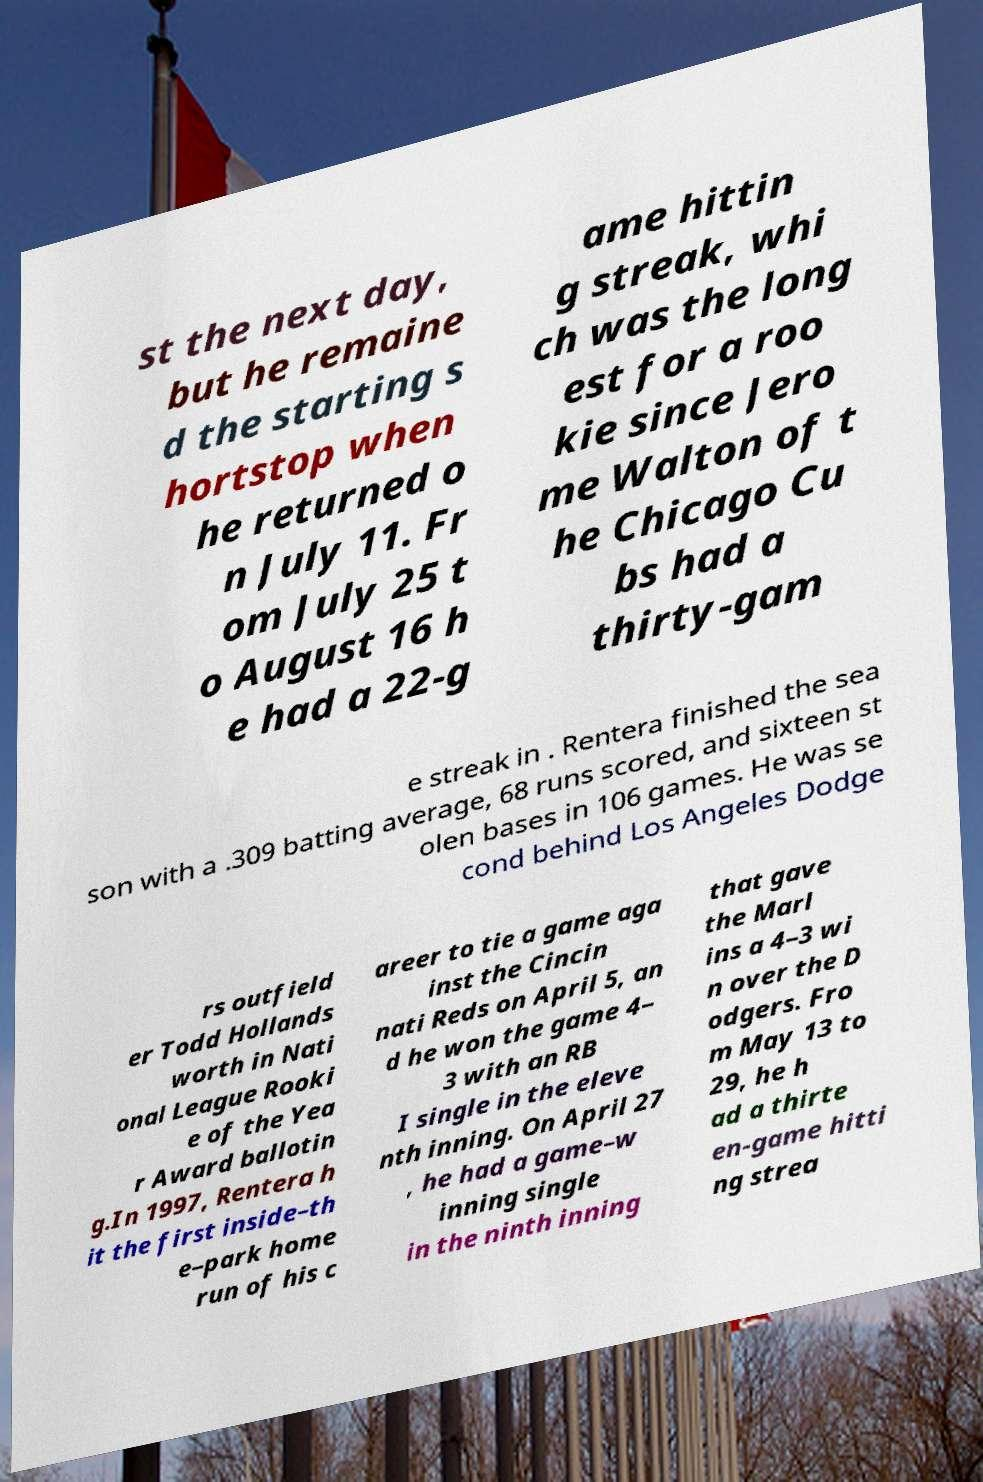Could you assist in decoding the text presented in this image and type it out clearly? st the next day, but he remaine d the starting s hortstop when he returned o n July 11. Fr om July 25 t o August 16 h e had a 22-g ame hittin g streak, whi ch was the long est for a roo kie since Jero me Walton of t he Chicago Cu bs had a thirty-gam e streak in . Rentera finished the sea son with a .309 batting average, 68 runs scored, and sixteen st olen bases in 106 games. He was se cond behind Los Angeles Dodge rs outfield er Todd Hollands worth in Nati onal League Rooki e of the Yea r Award ballotin g.In 1997, Rentera h it the first inside–th e–park home run of his c areer to tie a game aga inst the Cincin nati Reds on April 5, an d he won the game 4– 3 with an RB I single in the eleve nth inning. On April 27 , he had a game–w inning single in the ninth inning that gave the Marl ins a 4–3 wi n over the D odgers. Fro m May 13 to 29, he h ad a thirte en-game hitti ng strea 